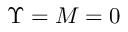<formula> <loc_0><loc_0><loc_500><loc_500>\Upsilon = M = 0</formula> 